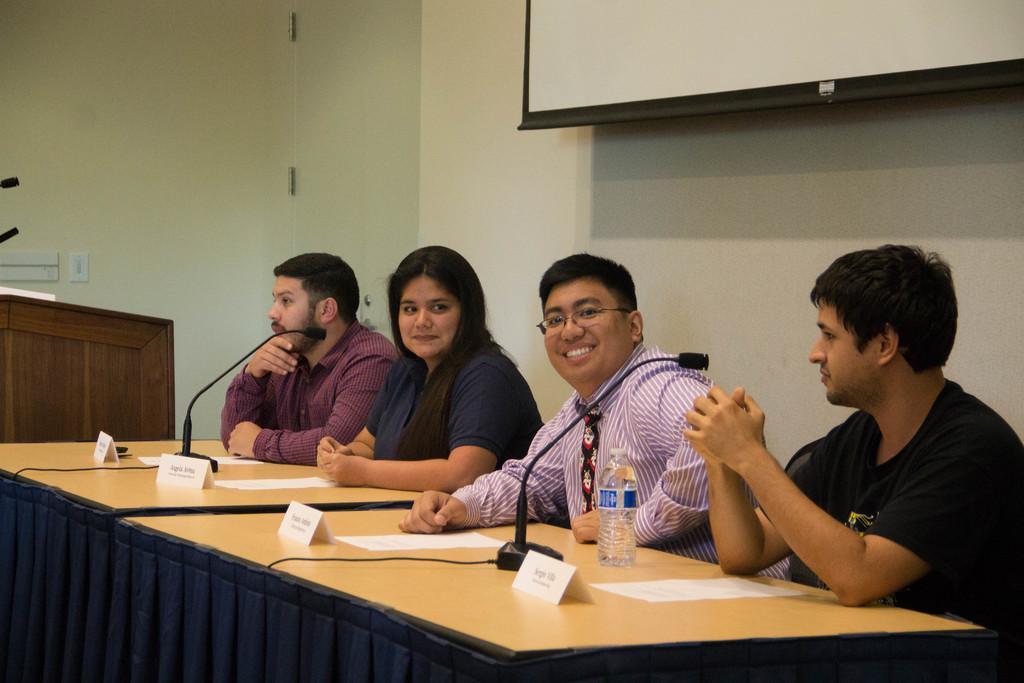In one or two sentences, can you explain what this image depicts? In this image people are sitting on chairs. In-front of them there are tables, above the tables there are mice, name boards, papers and a bottle. In the background we can see podium, wall and screen.   